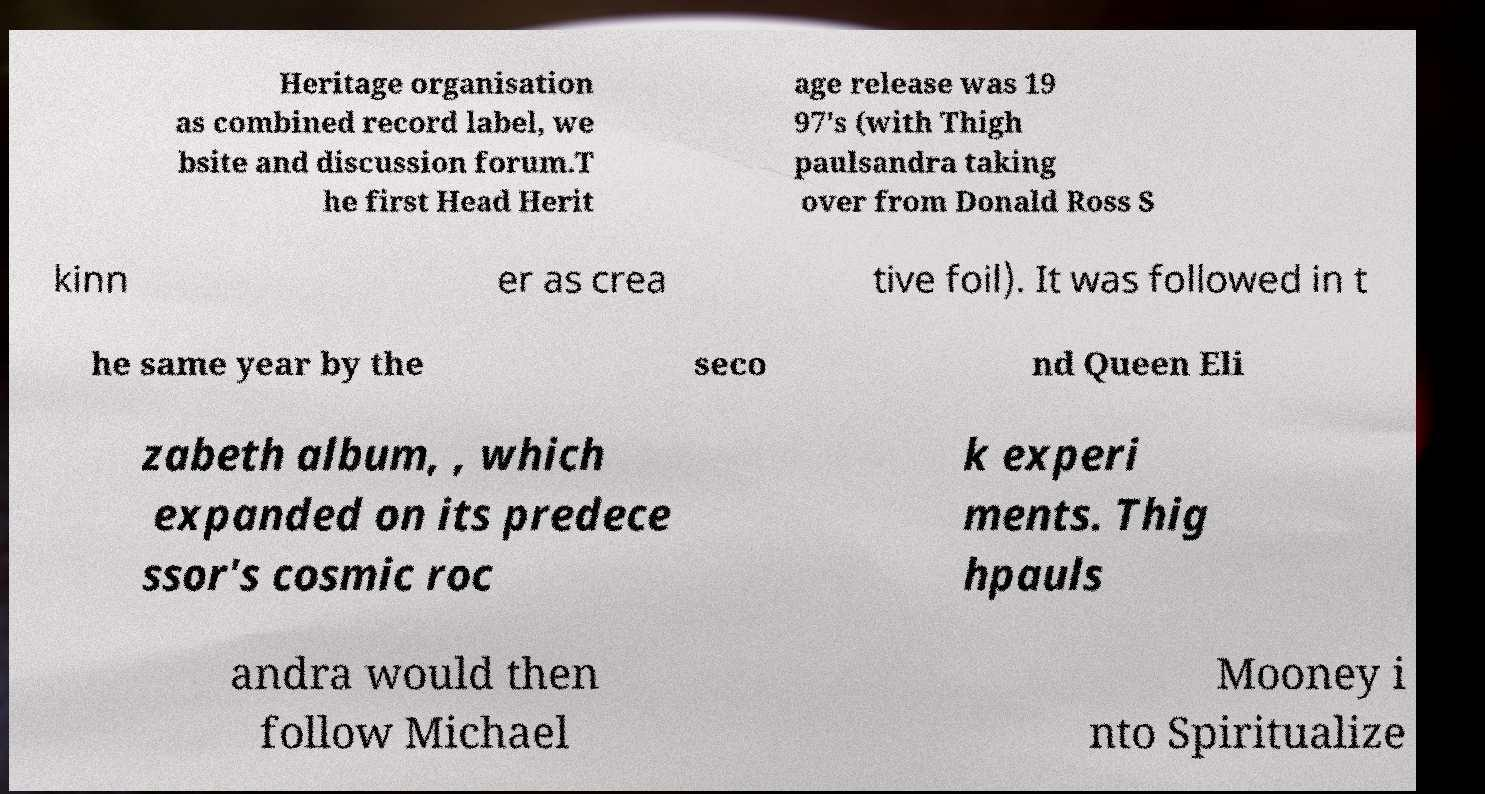Could you extract and type out the text from this image? Heritage organisation as combined record label, we bsite and discussion forum.T he first Head Herit age release was 19 97's (with Thigh paulsandra taking over from Donald Ross S kinn er as crea tive foil). It was followed in t he same year by the seco nd Queen Eli zabeth album, , which expanded on its predece ssor's cosmic roc k experi ments. Thig hpauls andra would then follow Michael Mooney i nto Spiritualize 